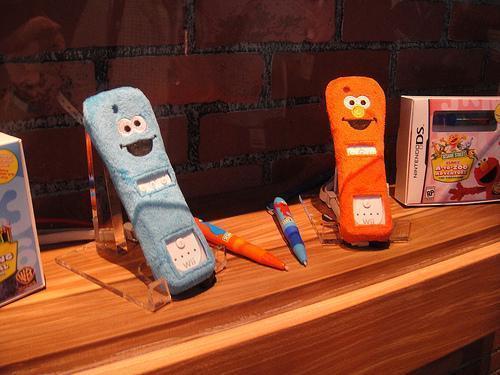How many pens are there?
Give a very brief answer. 2. How many pens?
Give a very brief answer. 2. How many covers?
Give a very brief answer. 2. How many video games?
Give a very brief answer. 2. 